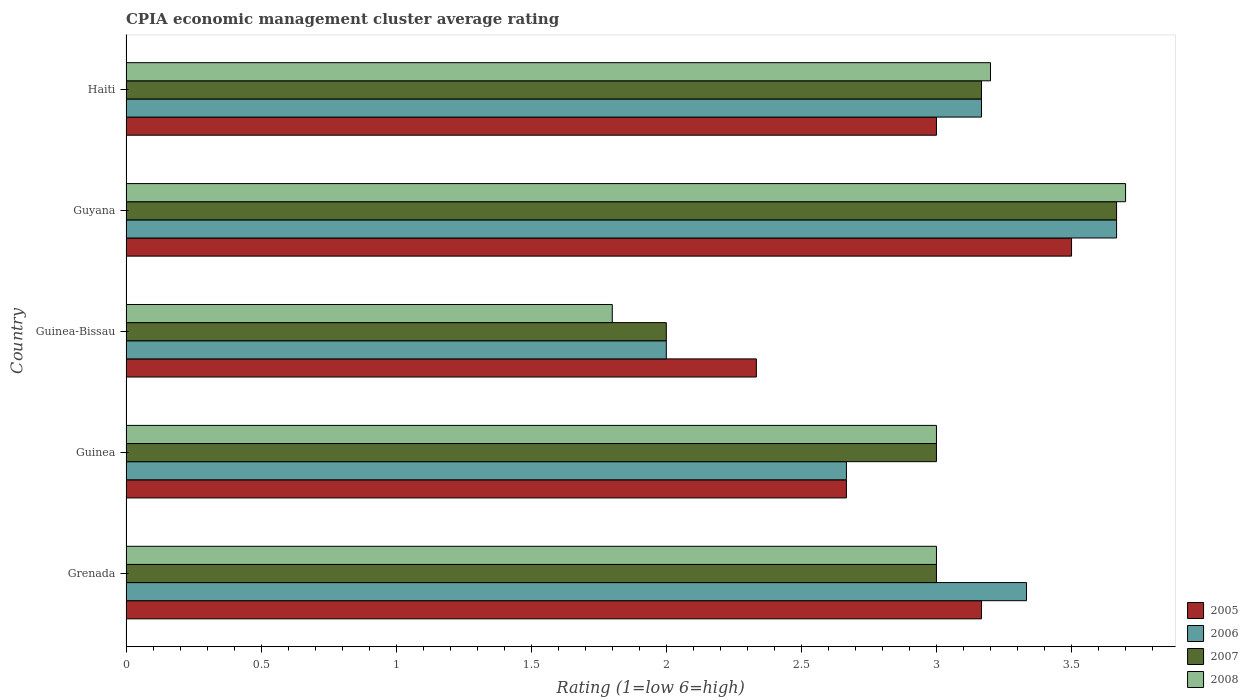How many different coloured bars are there?
Give a very brief answer. 4. Are the number of bars per tick equal to the number of legend labels?
Give a very brief answer. Yes. Are the number of bars on each tick of the Y-axis equal?
Your answer should be compact. Yes. How many bars are there on the 5th tick from the top?
Provide a succinct answer. 4. How many bars are there on the 4th tick from the bottom?
Offer a terse response. 4. What is the label of the 2nd group of bars from the top?
Your response must be concise. Guyana. What is the CPIA rating in 2006 in Guyana?
Ensure brevity in your answer.  3.67. Across all countries, what is the maximum CPIA rating in 2006?
Ensure brevity in your answer.  3.67. In which country was the CPIA rating in 2008 maximum?
Provide a short and direct response. Guyana. In which country was the CPIA rating in 2008 minimum?
Give a very brief answer. Guinea-Bissau. What is the difference between the CPIA rating in 2005 in Guinea and the CPIA rating in 2007 in Guinea-Bissau?
Give a very brief answer. 0.67. What is the average CPIA rating in 2005 per country?
Provide a succinct answer. 2.93. What is the difference between the CPIA rating in 2007 and CPIA rating in 2006 in Grenada?
Offer a very short reply. -0.33. In how many countries, is the CPIA rating in 2007 greater than 0.30000000000000004 ?
Make the answer very short. 5. What is the ratio of the CPIA rating in 2008 in Guinea to that in Guinea-Bissau?
Your response must be concise. 1.67. Is the CPIA rating in 2005 in Guinea less than that in Haiti?
Offer a terse response. Yes. What is the difference between the highest and the second highest CPIA rating in 2008?
Make the answer very short. 0.5. What is the difference between the highest and the lowest CPIA rating in 2006?
Keep it short and to the point. 1.67. Is the sum of the CPIA rating in 2006 in Guinea and Guinea-Bissau greater than the maximum CPIA rating in 2005 across all countries?
Provide a succinct answer. Yes. What does the 3rd bar from the top in Haiti represents?
Give a very brief answer. 2006. Is it the case that in every country, the sum of the CPIA rating in 2005 and CPIA rating in 2006 is greater than the CPIA rating in 2007?
Offer a very short reply. Yes. How many bars are there?
Your answer should be very brief. 20. How many countries are there in the graph?
Ensure brevity in your answer.  5. Are the values on the major ticks of X-axis written in scientific E-notation?
Ensure brevity in your answer.  No. Does the graph contain grids?
Give a very brief answer. No. How many legend labels are there?
Offer a very short reply. 4. How are the legend labels stacked?
Ensure brevity in your answer.  Vertical. What is the title of the graph?
Provide a succinct answer. CPIA economic management cluster average rating. Does "1975" appear as one of the legend labels in the graph?
Give a very brief answer. No. What is the label or title of the X-axis?
Ensure brevity in your answer.  Rating (1=low 6=high). What is the label or title of the Y-axis?
Provide a succinct answer. Country. What is the Rating (1=low 6=high) of 2005 in Grenada?
Provide a succinct answer. 3.17. What is the Rating (1=low 6=high) of 2006 in Grenada?
Offer a very short reply. 3.33. What is the Rating (1=low 6=high) of 2007 in Grenada?
Your answer should be compact. 3. What is the Rating (1=low 6=high) of 2005 in Guinea?
Give a very brief answer. 2.67. What is the Rating (1=low 6=high) in 2006 in Guinea?
Offer a terse response. 2.67. What is the Rating (1=low 6=high) of 2007 in Guinea?
Provide a short and direct response. 3. What is the Rating (1=low 6=high) of 2008 in Guinea?
Your answer should be very brief. 3. What is the Rating (1=low 6=high) of 2005 in Guinea-Bissau?
Offer a terse response. 2.33. What is the Rating (1=low 6=high) in 2007 in Guinea-Bissau?
Your response must be concise. 2. What is the Rating (1=low 6=high) in 2006 in Guyana?
Keep it short and to the point. 3.67. What is the Rating (1=low 6=high) in 2007 in Guyana?
Ensure brevity in your answer.  3.67. What is the Rating (1=low 6=high) of 2008 in Guyana?
Provide a succinct answer. 3.7. What is the Rating (1=low 6=high) in 2006 in Haiti?
Your response must be concise. 3.17. What is the Rating (1=low 6=high) of 2007 in Haiti?
Your answer should be compact. 3.17. Across all countries, what is the maximum Rating (1=low 6=high) in 2005?
Offer a very short reply. 3.5. Across all countries, what is the maximum Rating (1=low 6=high) in 2006?
Your answer should be very brief. 3.67. Across all countries, what is the maximum Rating (1=low 6=high) of 2007?
Offer a very short reply. 3.67. Across all countries, what is the minimum Rating (1=low 6=high) of 2005?
Provide a succinct answer. 2.33. Across all countries, what is the minimum Rating (1=low 6=high) of 2006?
Make the answer very short. 2. Across all countries, what is the minimum Rating (1=low 6=high) of 2008?
Your answer should be very brief. 1.8. What is the total Rating (1=low 6=high) in 2005 in the graph?
Give a very brief answer. 14.67. What is the total Rating (1=low 6=high) of 2006 in the graph?
Offer a terse response. 14.83. What is the total Rating (1=low 6=high) of 2007 in the graph?
Your answer should be compact. 14.83. What is the difference between the Rating (1=low 6=high) of 2005 in Grenada and that in Guinea?
Keep it short and to the point. 0.5. What is the difference between the Rating (1=low 6=high) in 2006 in Grenada and that in Guinea?
Give a very brief answer. 0.67. What is the difference between the Rating (1=low 6=high) of 2007 in Grenada and that in Guinea?
Keep it short and to the point. 0. What is the difference between the Rating (1=low 6=high) of 2008 in Grenada and that in Guinea?
Offer a very short reply. 0. What is the difference between the Rating (1=low 6=high) of 2005 in Grenada and that in Guinea-Bissau?
Keep it short and to the point. 0.83. What is the difference between the Rating (1=low 6=high) of 2008 in Grenada and that in Guinea-Bissau?
Give a very brief answer. 1.2. What is the difference between the Rating (1=low 6=high) of 2005 in Grenada and that in Guyana?
Offer a terse response. -0.33. What is the difference between the Rating (1=low 6=high) of 2008 in Grenada and that in Guyana?
Give a very brief answer. -0.7. What is the difference between the Rating (1=low 6=high) in 2007 in Grenada and that in Haiti?
Provide a succinct answer. -0.17. What is the difference between the Rating (1=low 6=high) of 2005 in Guinea and that in Guinea-Bissau?
Your answer should be very brief. 0.33. What is the difference between the Rating (1=low 6=high) in 2007 in Guinea and that in Guinea-Bissau?
Your answer should be compact. 1. What is the difference between the Rating (1=low 6=high) of 2007 in Guinea and that in Guyana?
Ensure brevity in your answer.  -0.67. What is the difference between the Rating (1=low 6=high) in 2005 in Guinea-Bissau and that in Guyana?
Provide a succinct answer. -1.17. What is the difference between the Rating (1=low 6=high) of 2006 in Guinea-Bissau and that in Guyana?
Offer a terse response. -1.67. What is the difference between the Rating (1=low 6=high) in 2007 in Guinea-Bissau and that in Guyana?
Keep it short and to the point. -1.67. What is the difference between the Rating (1=low 6=high) in 2006 in Guinea-Bissau and that in Haiti?
Give a very brief answer. -1.17. What is the difference between the Rating (1=low 6=high) in 2007 in Guinea-Bissau and that in Haiti?
Your answer should be very brief. -1.17. What is the difference between the Rating (1=low 6=high) in 2008 in Guinea-Bissau and that in Haiti?
Provide a short and direct response. -1.4. What is the difference between the Rating (1=low 6=high) of 2005 in Guyana and that in Haiti?
Ensure brevity in your answer.  0.5. What is the difference between the Rating (1=low 6=high) in 2007 in Guyana and that in Haiti?
Keep it short and to the point. 0.5. What is the difference between the Rating (1=low 6=high) in 2008 in Guyana and that in Haiti?
Your answer should be very brief. 0.5. What is the difference between the Rating (1=low 6=high) of 2005 in Grenada and the Rating (1=low 6=high) of 2008 in Guinea?
Your response must be concise. 0.17. What is the difference between the Rating (1=low 6=high) in 2006 in Grenada and the Rating (1=low 6=high) in 2007 in Guinea?
Offer a very short reply. 0.33. What is the difference between the Rating (1=low 6=high) of 2006 in Grenada and the Rating (1=low 6=high) of 2008 in Guinea?
Offer a very short reply. 0.33. What is the difference between the Rating (1=low 6=high) in 2005 in Grenada and the Rating (1=low 6=high) in 2008 in Guinea-Bissau?
Keep it short and to the point. 1.37. What is the difference between the Rating (1=low 6=high) in 2006 in Grenada and the Rating (1=low 6=high) in 2007 in Guinea-Bissau?
Your answer should be compact. 1.33. What is the difference between the Rating (1=low 6=high) of 2006 in Grenada and the Rating (1=low 6=high) of 2008 in Guinea-Bissau?
Give a very brief answer. 1.53. What is the difference between the Rating (1=low 6=high) of 2005 in Grenada and the Rating (1=low 6=high) of 2008 in Guyana?
Make the answer very short. -0.53. What is the difference between the Rating (1=low 6=high) of 2006 in Grenada and the Rating (1=low 6=high) of 2008 in Guyana?
Give a very brief answer. -0.37. What is the difference between the Rating (1=low 6=high) of 2007 in Grenada and the Rating (1=low 6=high) of 2008 in Guyana?
Offer a terse response. -0.7. What is the difference between the Rating (1=low 6=high) of 2005 in Grenada and the Rating (1=low 6=high) of 2008 in Haiti?
Give a very brief answer. -0.03. What is the difference between the Rating (1=low 6=high) of 2006 in Grenada and the Rating (1=low 6=high) of 2008 in Haiti?
Give a very brief answer. 0.13. What is the difference between the Rating (1=low 6=high) in 2005 in Guinea and the Rating (1=low 6=high) in 2008 in Guinea-Bissau?
Provide a short and direct response. 0.87. What is the difference between the Rating (1=low 6=high) of 2006 in Guinea and the Rating (1=low 6=high) of 2007 in Guinea-Bissau?
Give a very brief answer. 0.67. What is the difference between the Rating (1=low 6=high) in 2006 in Guinea and the Rating (1=low 6=high) in 2008 in Guinea-Bissau?
Offer a very short reply. 0.87. What is the difference between the Rating (1=low 6=high) of 2007 in Guinea and the Rating (1=low 6=high) of 2008 in Guinea-Bissau?
Your answer should be compact. 1.2. What is the difference between the Rating (1=low 6=high) of 2005 in Guinea and the Rating (1=low 6=high) of 2006 in Guyana?
Offer a very short reply. -1. What is the difference between the Rating (1=low 6=high) in 2005 in Guinea and the Rating (1=low 6=high) in 2007 in Guyana?
Offer a very short reply. -1. What is the difference between the Rating (1=low 6=high) of 2005 in Guinea and the Rating (1=low 6=high) of 2008 in Guyana?
Provide a succinct answer. -1.03. What is the difference between the Rating (1=low 6=high) in 2006 in Guinea and the Rating (1=low 6=high) in 2007 in Guyana?
Offer a terse response. -1. What is the difference between the Rating (1=low 6=high) in 2006 in Guinea and the Rating (1=low 6=high) in 2008 in Guyana?
Keep it short and to the point. -1.03. What is the difference between the Rating (1=low 6=high) in 2007 in Guinea and the Rating (1=low 6=high) in 2008 in Guyana?
Provide a short and direct response. -0.7. What is the difference between the Rating (1=low 6=high) in 2005 in Guinea and the Rating (1=low 6=high) in 2006 in Haiti?
Offer a very short reply. -0.5. What is the difference between the Rating (1=low 6=high) in 2005 in Guinea and the Rating (1=low 6=high) in 2007 in Haiti?
Provide a succinct answer. -0.5. What is the difference between the Rating (1=low 6=high) in 2005 in Guinea and the Rating (1=low 6=high) in 2008 in Haiti?
Your answer should be compact. -0.53. What is the difference between the Rating (1=low 6=high) in 2006 in Guinea and the Rating (1=low 6=high) in 2008 in Haiti?
Your response must be concise. -0.53. What is the difference between the Rating (1=low 6=high) in 2007 in Guinea and the Rating (1=low 6=high) in 2008 in Haiti?
Offer a very short reply. -0.2. What is the difference between the Rating (1=low 6=high) in 2005 in Guinea-Bissau and the Rating (1=low 6=high) in 2006 in Guyana?
Give a very brief answer. -1.33. What is the difference between the Rating (1=low 6=high) in 2005 in Guinea-Bissau and the Rating (1=low 6=high) in 2007 in Guyana?
Ensure brevity in your answer.  -1.33. What is the difference between the Rating (1=low 6=high) of 2005 in Guinea-Bissau and the Rating (1=low 6=high) of 2008 in Guyana?
Give a very brief answer. -1.37. What is the difference between the Rating (1=low 6=high) of 2006 in Guinea-Bissau and the Rating (1=low 6=high) of 2007 in Guyana?
Your answer should be compact. -1.67. What is the difference between the Rating (1=low 6=high) in 2006 in Guinea-Bissau and the Rating (1=low 6=high) in 2008 in Guyana?
Ensure brevity in your answer.  -1.7. What is the difference between the Rating (1=low 6=high) in 2005 in Guinea-Bissau and the Rating (1=low 6=high) in 2008 in Haiti?
Give a very brief answer. -0.87. What is the difference between the Rating (1=low 6=high) of 2006 in Guinea-Bissau and the Rating (1=low 6=high) of 2007 in Haiti?
Ensure brevity in your answer.  -1.17. What is the difference between the Rating (1=low 6=high) of 2006 in Guyana and the Rating (1=low 6=high) of 2007 in Haiti?
Make the answer very short. 0.5. What is the difference between the Rating (1=low 6=high) of 2006 in Guyana and the Rating (1=low 6=high) of 2008 in Haiti?
Provide a short and direct response. 0.47. What is the difference between the Rating (1=low 6=high) of 2007 in Guyana and the Rating (1=low 6=high) of 2008 in Haiti?
Offer a terse response. 0.47. What is the average Rating (1=low 6=high) of 2005 per country?
Your response must be concise. 2.93. What is the average Rating (1=low 6=high) in 2006 per country?
Provide a short and direct response. 2.97. What is the average Rating (1=low 6=high) of 2007 per country?
Ensure brevity in your answer.  2.97. What is the average Rating (1=low 6=high) of 2008 per country?
Keep it short and to the point. 2.94. What is the difference between the Rating (1=low 6=high) of 2005 and Rating (1=low 6=high) of 2006 in Grenada?
Give a very brief answer. -0.17. What is the difference between the Rating (1=low 6=high) in 2005 and Rating (1=low 6=high) in 2008 in Grenada?
Your response must be concise. 0.17. What is the difference between the Rating (1=low 6=high) of 2006 and Rating (1=low 6=high) of 2008 in Grenada?
Offer a terse response. 0.33. What is the difference between the Rating (1=low 6=high) in 2005 and Rating (1=low 6=high) in 2006 in Guinea?
Offer a very short reply. 0. What is the difference between the Rating (1=low 6=high) in 2005 and Rating (1=low 6=high) in 2007 in Guinea?
Your answer should be very brief. -0.33. What is the difference between the Rating (1=low 6=high) of 2005 and Rating (1=low 6=high) of 2008 in Guinea?
Offer a terse response. -0.33. What is the difference between the Rating (1=low 6=high) of 2005 and Rating (1=low 6=high) of 2006 in Guinea-Bissau?
Give a very brief answer. 0.33. What is the difference between the Rating (1=low 6=high) of 2005 and Rating (1=low 6=high) of 2008 in Guinea-Bissau?
Give a very brief answer. 0.53. What is the difference between the Rating (1=low 6=high) of 2005 and Rating (1=low 6=high) of 2006 in Guyana?
Make the answer very short. -0.17. What is the difference between the Rating (1=low 6=high) of 2006 and Rating (1=low 6=high) of 2008 in Guyana?
Offer a terse response. -0.03. What is the difference between the Rating (1=low 6=high) of 2007 and Rating (1=low 6=high) of 2008 in Guyana?
Your response must be concise. -0.03. What is the difference between the Rating (1=low 6=high) of 2005 and Rating (1=low 6=high) of 2006 in Haiti?
Provide a succinct answer. -0.17. What is the difference between the Rating (1=low 6=high) of 2005 and Rating (1=low 6=high) of 2007 in Haiti?
Give a very brief answer. -0.17. What is the difference between the Rating (1=low 6=high) in 2006 and Rating (1=low 6=high) in 2008 in Haiti?
Make the answer very short. -0.03. What is the difference between the Rating (1=low 6=high) of 2007 and Rating (1=low 6=high) of 2008 in Haiti?
Provide a succinct answer. -0.03. What is the ratio of the Rating (1=low 6=high) of 2005 in Grenada to that in Guinea?
Your answer should be compact. 1.19. What is the ratio of the Rating (1=low 6=high) of 2006 in Grenada to that in Guinea?
Provide a short and direct response. 1.25. What is the ratio of the Rating (1=low 6=high) in 2007 in Grenada to that in Guinea?
Give a very brief answer. 1. What is the ratio of the Rating (1=low 6=high) of 2008 in Grenada to that in Guinea?
Make the answer very short. 1. What is the ratio of the Rating (1=low 6=high) of 2005 in Grenada to that in Guinea-Bissau?
Your response must be concise. 1.36. What is the ratio of the Rating (1=low 6=high) of 2006 in Grenada to that in Guinea-Bissau?
Keep it short and to the point. 1.67. What is the ratio of the Rating (1=low 6=high) of 2005 in Grenada to that in Guyana?
Give a very brief answer. 0.9. What is the ratio of the Rating (1=low 6=high) in 2007 in Grenada to that in Guyana?
Offer a very short reply. 0.82. What is the ratio of the Rating (1=low 6=high) of 2008 in Grenada to that in Guyana?
Ensure brevity in your answer.  0.81. What is the ratio of the Rating (1=low 6=high) in 2005 in Grenada to that in Haiti?
Offer a terse response. 1.06. What is the ratio of the Rating (1=low 6=high) of 2006 in Grenada to that in Haiti?
Your response must be concise. 1.05. What is the ratio of the Rating (1=low 6=high) in 2007 in Grenada to that in Haiti?
Offer a very short reply. 0.95. What is the ratio of the Rating (1=low 6=high) in 2005 in Guinea to that in Guinea-Bissau?
Your answer should be compact. 1.14. What is the ratio of the Rating (1=low 6=high) in 2007 in Guinea to that in Guinea-Bissau?
Give a very brief answer. 1.5. What is the ratio of the Rating (1=low 6=high) of 2005 in Guinea to that in Guyana?
Keep it short and to the point. 0.76. What is the ratio of the Rating (1=low 6=high) of 2006 in Guinea to that in Guyana?
Your answer should be very brief. 0.73. What is the ratio of the Rating (1=low 6=high) in 2007 in Guinea to that in Guyana?
Make the answer very short. 0.82. What is the ratio of the Rating (1=low 6=high) in 2008 in Guinea to that in Guyana?
Offer a very short reply. 0.81. What is the ratio of the Rating (1=low 6=high) of 2006 in Guinea to that in Haiti?
Your answer should be very brief. 0.84. What is the ratio of the Rating (1=low 6=high) in 2007 in Guinea to that in Haiti?
Your answer should be compact. 0.95. What is the ratio of the Rating (1=low 6=high) of 2006 in Guinea-Bissau to that in Guyana?
Provide a succinct answer. 0.55. What is the ratio of the Rating (1=low 6=high) of 2007 in Guinea-Bissau to that in Guyana?
Ensure brevity in your answer.  0.55. What is the ratio of the Rating (1=low 6=high) of 2008 in Guinea-Bissau to that in Guyana?
Give a very brief answer. 0.49. What is the ratio of the Rating (1=low 6=high) of 2006 in Guinea-Bissau to that in Haiti?
Provide a succinct answer. 0.63. What is the ratio of the Rating (1=low 6=high) in 2007 in Guinea-Bissau to that in Haiti?
Provide a succinct answer. 0.63. What is the ratio of the Rating (1=low 6=high) in 2008 in Guinea-Bissau to that in Haiti?
Offer a terse response. 0.56. What is the ratio of the Rating (1=low 6=high) in 2005 in Guyana to that in Haiti?
Offer a very short reply. 1.17. What is the ratio of the Rating (1=low 6=high) in 2006 in Guyana to that in Haiti?
Your answer should be compact. 1.16. What is the ratio of the Rating (1=low 6=high) in 2007 in Guyana to that in Haiti?
Give a very brief answer. 1.16. What is the ratio of the Rating (1=low 6=high) of 2008 in Guyana to that in Haiti?
Ensure brevity in your answer.  1.16. What is the difference between the highest and the second highest Rating (1=low 6=high) in 2005?
Make the answer very short. 0.33. What is the difference between the highest and the second highest Rating (1=low 6=high) in 2006?
Offer a very short reply. 0.33. What is the difference between the highest and the second highest Rating (1=low 6=high) of 2007?
Ensure brevity in your answer.  0.5. What is the difference between the highest and the lowest Rating (1=low 6=high) in 2008?
Keep it short and to the point. 1.9. 